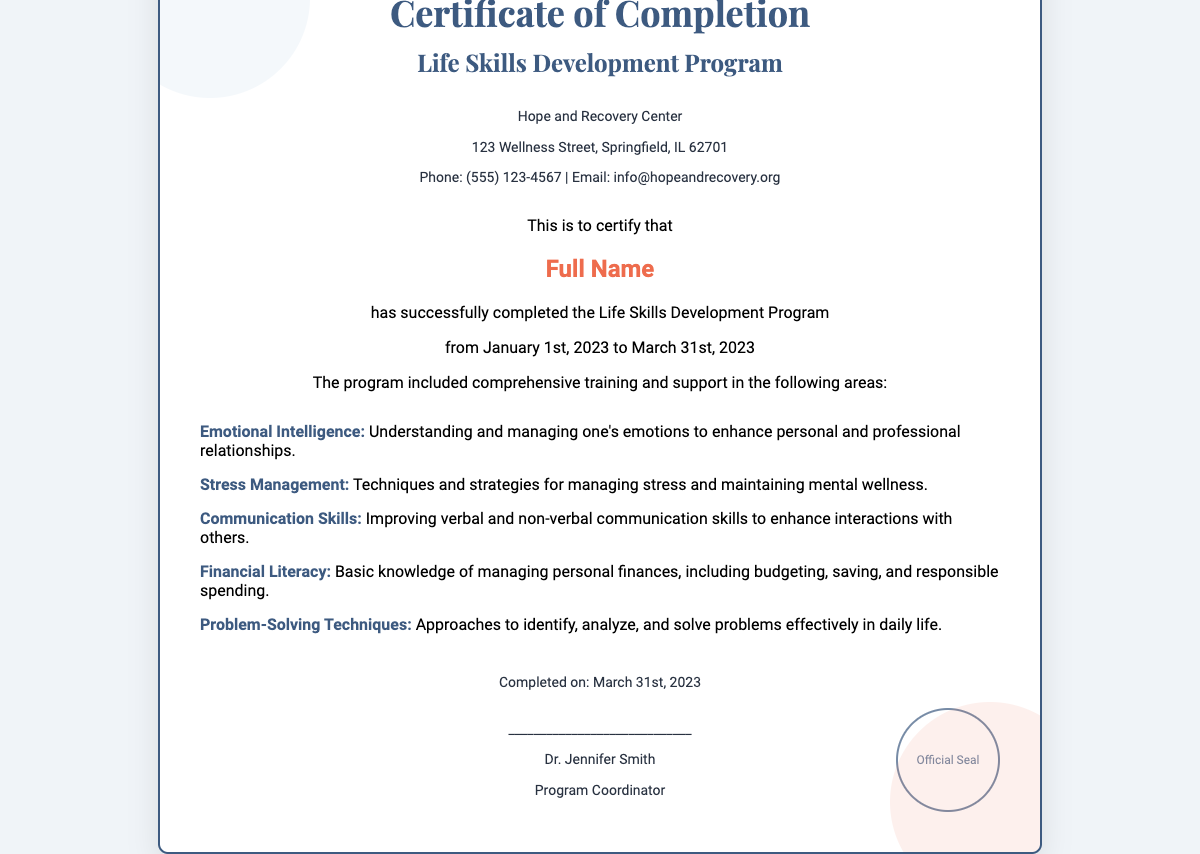what is the name of the program? The program title is mentioned as the "Life Skills Development Program."
Answer: Life Skills Development Program who completed the program? The certificate specifies "Full Name" as a placeholder for the participant.
Answer: Full Name when did the program start and end? The dates for the program are listed from "January 1st, 2023" to "March 31st, 2023."
Answer: January 1st, 2023 to March 31st, 2023 who is the program coordinator? The name of the program coordinator is "Dr. Jennifer Smith," as stated in the footer.
Answer: Dr. Jennifer Smith how many areas of training were mentioned? The program elements section lists five specific areas of training.
Answer: Five what is one of the skills taught in the program? The document highlights several skills; one example is "Emotional Intelligence."
Answer: Emotional Intelligence where is the Hope and Recovery Center located? The address of the Hope and Recovery Center is specified in the header as "123 Wellness Street, Springfield, IL 62701."
Answer: 123 Wellness Street, Springfield, IL 62701 what is the phone number for the Hope and Recovery Center? The contact number for the center is "(555) 123-4567," as noted in the document.
Answer: (555) 123-4567 what does the official seal say? The seal at the bottom right states "Official Seal," as mentioned in the document.
Answer: Official Seal 